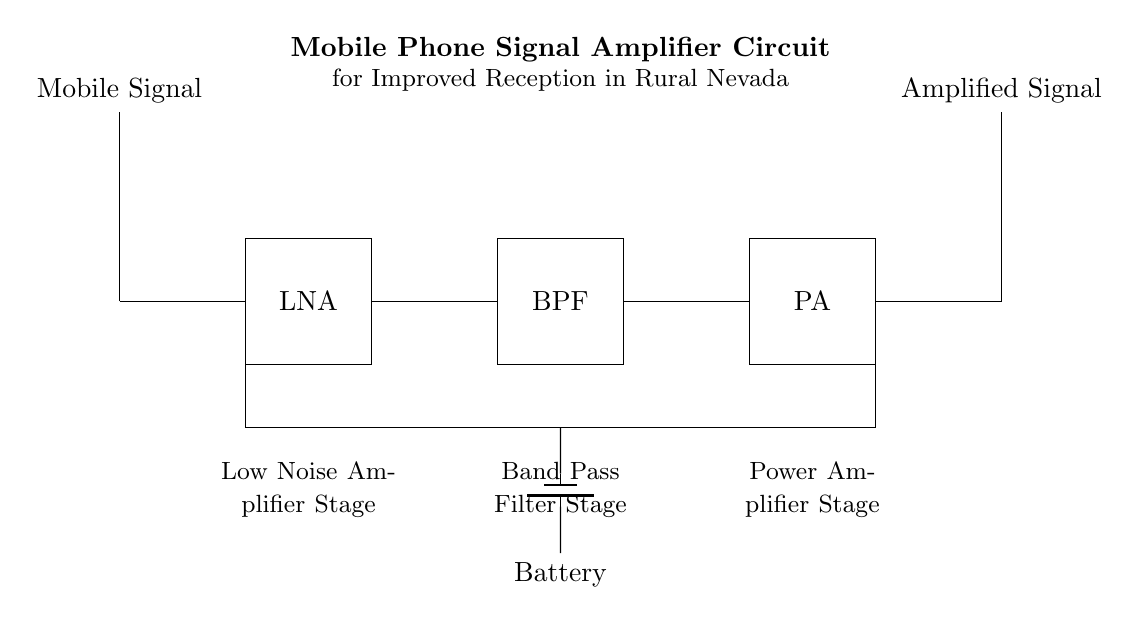What is the first component connected to the input signal? The first component is the Low Noise Amplifier (LNA), which amplifies the weak mobile signal received from the antenna.
Answer: Low Noise Amplifier What type of filter is used in the circuit? The circuit uses a Band Pass Filter (BPF), which allows signals within a certain frequency range to pass and attenuates others, ensuring only the desired frequencies are amplified.
Answer: Band Pass Filter What does PA stand for in this circuit? PA stands for Power Amplifier, which increases the power level of the signal to ensure it can reach the output antenna effectively.
Answer: Power Amplifier Which component is responsible for improving weak mobile signals? The component responsible for improving weak mobile signals is the LNA, as it amplifies the low-level signals before they pass through the rest of the circuit.
Answer: Low Noise Amplifier How many main stages are present in this amplifier circuit? There are three main stages in this amplifier circuit, which are the Low Noise Amplifier, Band Pass Filter, and Power Amplifier, each serving a specific purpose in signal enhancement.
Answer: Three What type of energy source is used to power the circuit? The circuit is powered by a battery, which provides the necessary voltage to operate components like the LNA and PA.
Answer: Battery 